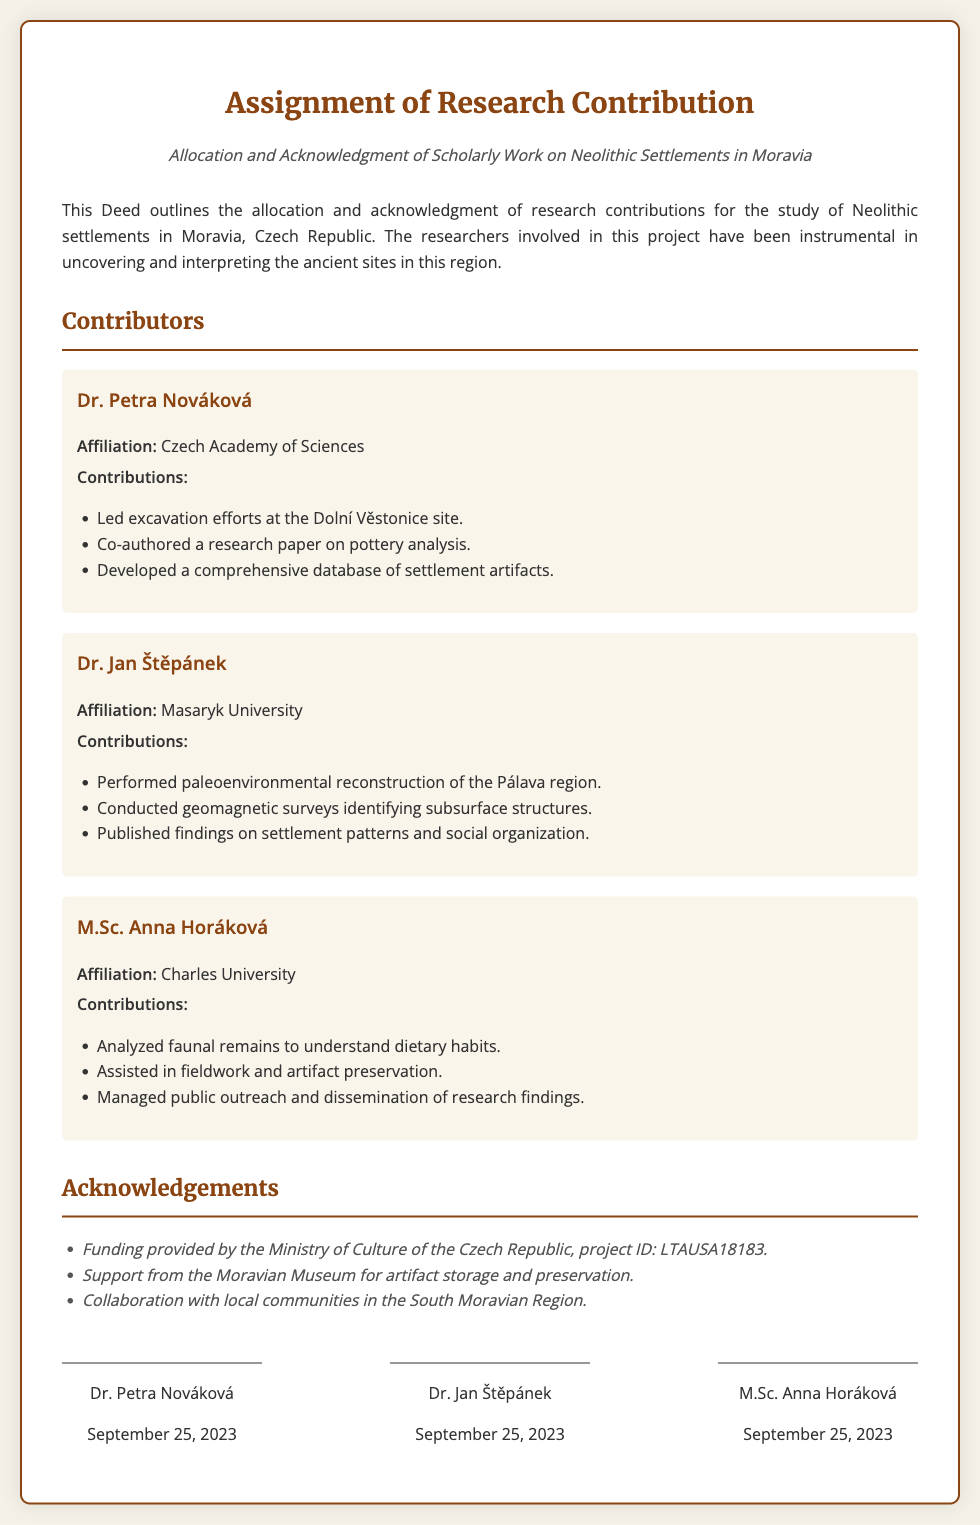What is the title of the document? The title of the document is found at the top, stating the purpose of the Deed.
Answer: Assignment of Research Contribution Who is associated with the Czech Academy of Sciences? This information can be found in the contributor's section, indicating affiliation.
Answer: Dr. Petra Nováková What date was the document signed? The date can be found below the signatures section, indicating when the signatories agreed to the deed.
Answer: September 25, 2023 Which site did Dr. Petra Nováková lead excavation efforts at? The specific site is mentioned in the contributions section under her name.
Answer: Dolní Věstonice What is the project ID mentioned in the acknowledgements? This number is specified as part of the funding acknowledgment in the document.
Answer: LTAUSA18183 What type of surveys did Dr. Jan Štěpánek conduct? The type of surveys is mentioned in his contributions, describing his work related to geological studies.
Answer: Geomagnetic surveys Which university is M.Sc. Anna Horáková affiliated with? This affiliation is clearly stated in the contributor's section of the document.
Answer: Charles University How many contributors are listed in the document? A count of the contributors can be deduced from the contributor section.
Answer: Three 